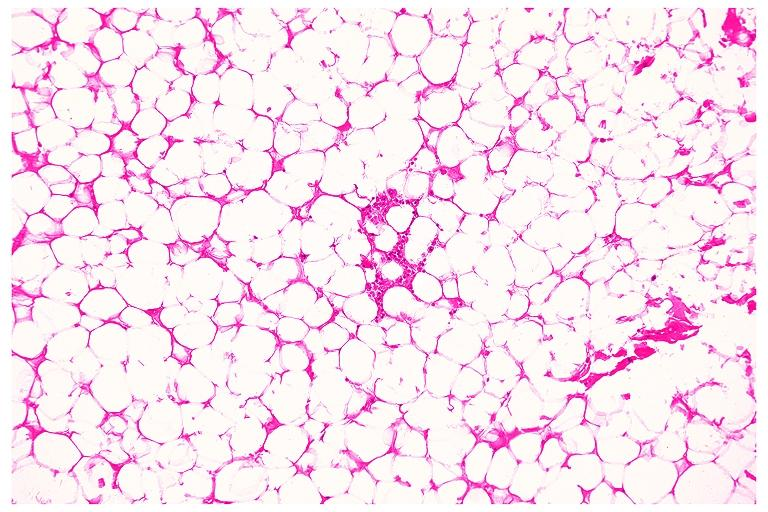what is present?
Answer the question using a single word or phrase. Oral 